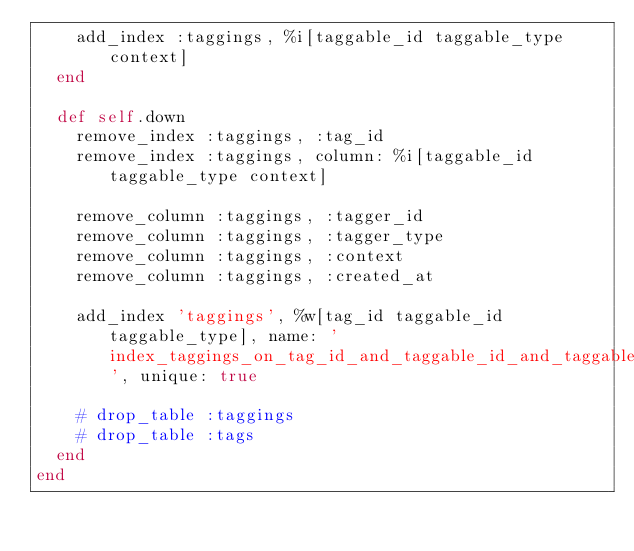<code> <loc_0><loc_0><loc_500><loc_500><_Ruby_>    add_index :taggings, %i[taggable_id taggable_type context]
  end

  def self.down
    remove_index :taggings, :tag_id
    remove_index :taggings, column: %i[taggable_id taggable_type context]

    remove_column :taggings, :tagger_id
    remove_column :taggings, :tagger_type
    remove_column :taggings, :context
    remove_column :taggings, :created_at

    add_index 'taggings', %w[tag_id taggable_id taggable_type], name: 'index_taggings_on_tag_id_and_taggable_id_and_taggable_type', unique: true

    # drop_table :taggings
    # drop_table :tags
  end
end
</code> 